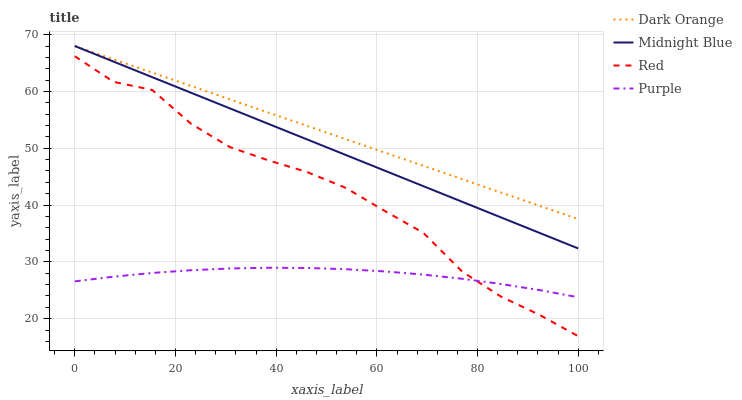Does Midnight Blue have the minimum area under the curve?
Answer yes or no. No. Does Midnight Blue have the maximum area under the curve?
Answer yes or no. No. Is Midnight Blue the smoothest?
Answer yes or no. No. Is Midnight Blue the roughest?
Answer yes or no. No. Does Midnight Blue have the lowest value?
Answer yes or no. No. Does Red have the highest value?
Answer yes or no. No. Is Purple less than Dark Orange?
Answer yes or no. Yes. Is Midnight Blue greater than Red?
Answer yes or no. Yes. Does Purple intersect Dark Orange?
Answer yes or no. No. 